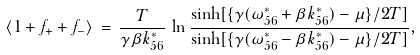Convert formula to latex. <formula><loc_0><loc_0><loc_500><loc_500>\langle 1 + f _ { + } + f _ { - } \rangle \, = \, \frac { T } { \gamma \beta k ^ { * } _ { 5 6 } } \, \ln \frac { \sinh [ \{ \gamma ( \omega ^ { * } _ { 5 6 } + \beta k ^ { * } _ { 5 6 } ) - \mu \} / 2 T ] } { \sinh [ \{ \gamma ( \omega ^ { * } _ { 5 6 } - \beta k ^ { * } _ { 5 6 } ) - \mu \} / 2 T ] } ,</formula> 